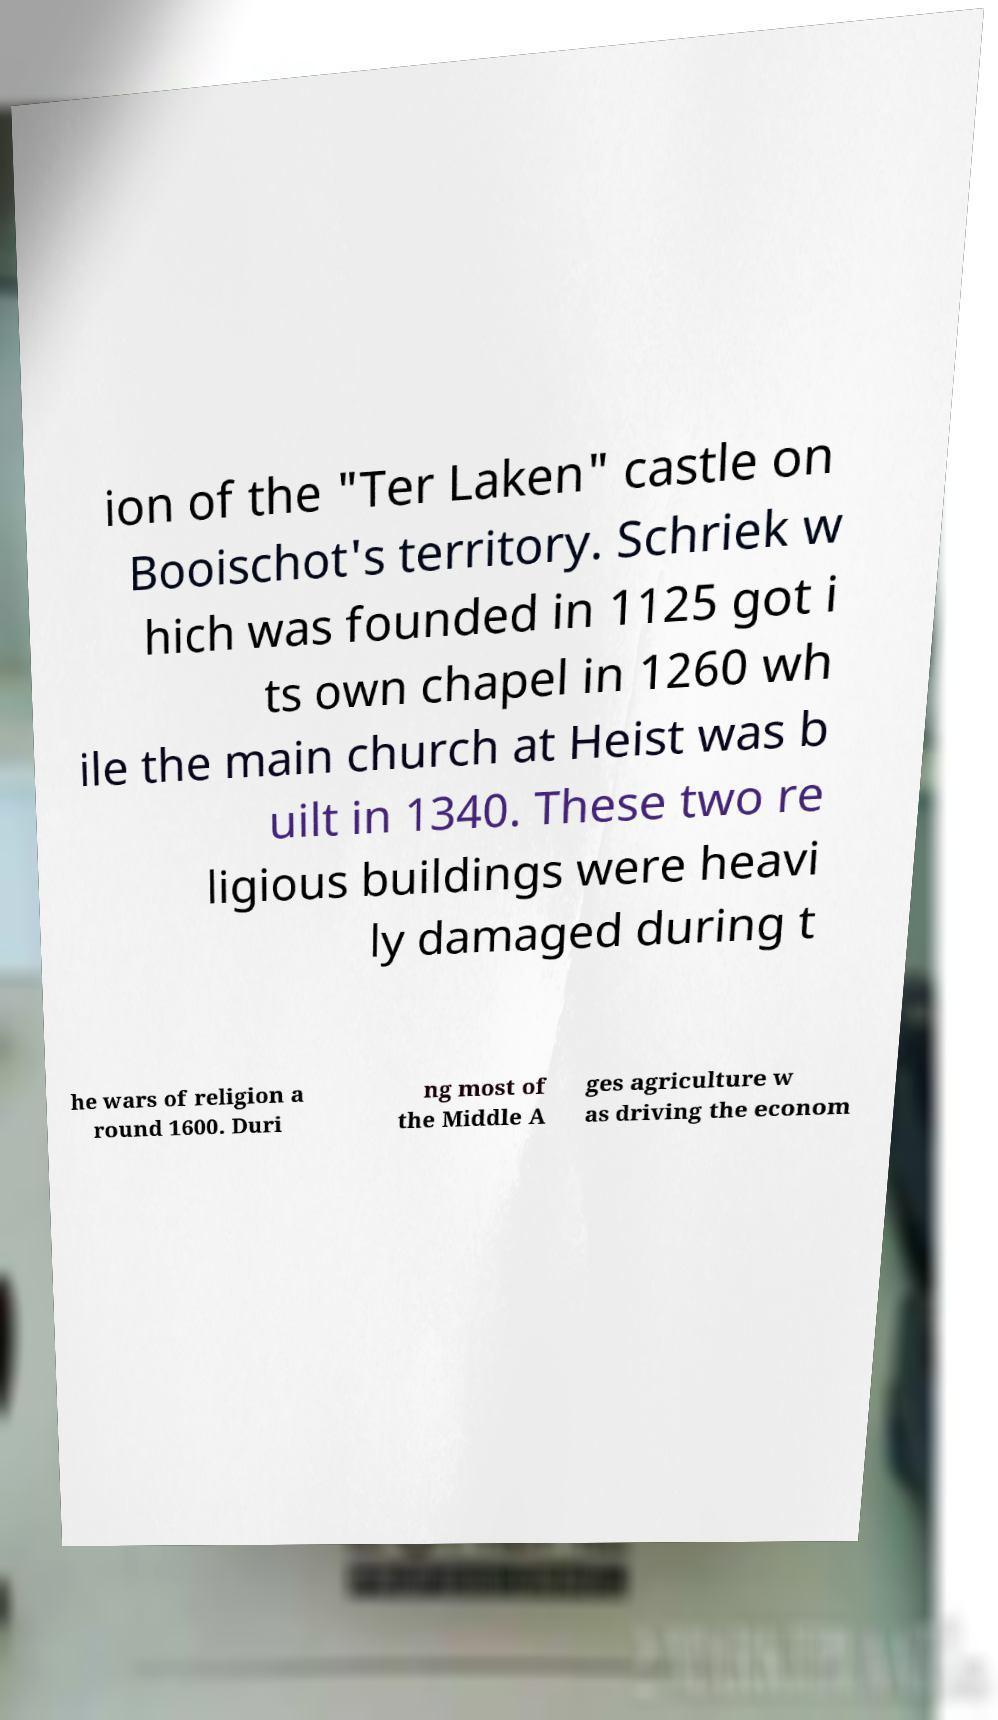Can you accurately transcribe the text from the provided image for me? ion of the "Ter Laken" castle on Booischot's territory. Schriek w hich was founded in 1125 got i ts own chapel in 1260 wh ile the main church at Heist was b uilt in 1340. These two re ligious buildings were heavi ly damaged during t he wars of religion a round 1600. Duri ng most of the Middle A ges agriculture w as driving the econom 